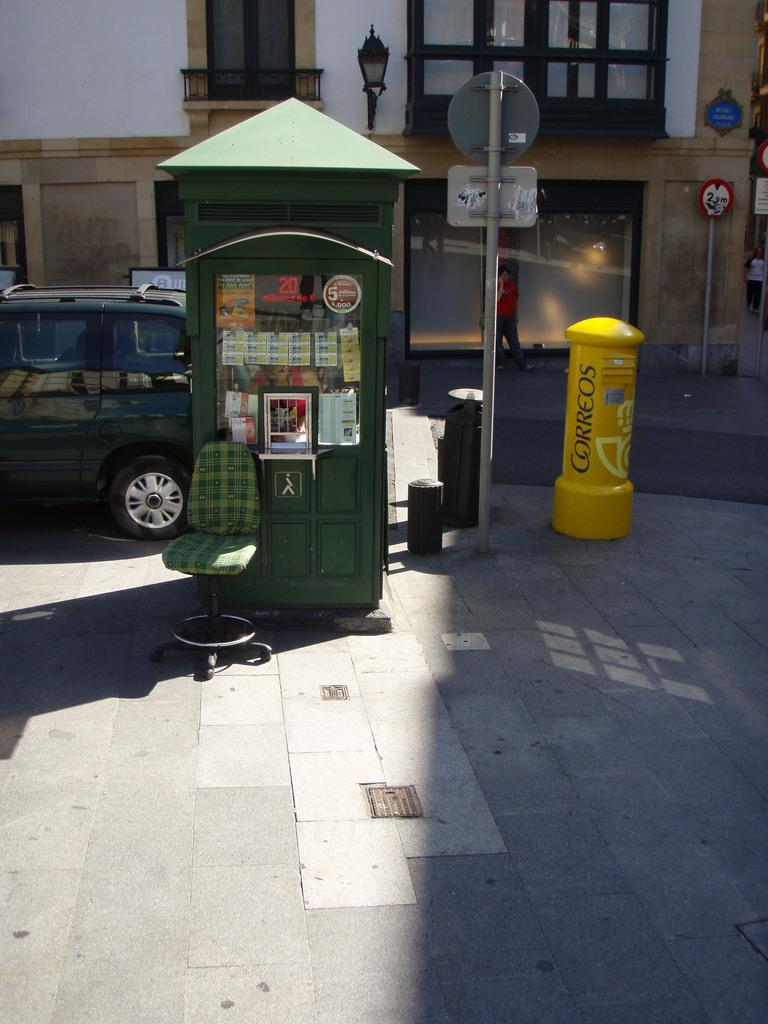What structure is the main subject of the image? There is a telephone booth in the image. What color is the telephone booth? The telephone booth is green. What is located in front of the telephone booth? There is a chair in front of the telephone booth. What can be seen in the background of the image? There is a building in the background of the image. What color is the building? The building is cream-colored. What type of animal can be seen walking on the floor in the image? There is no animal present in the image, and the floor is not visible. 